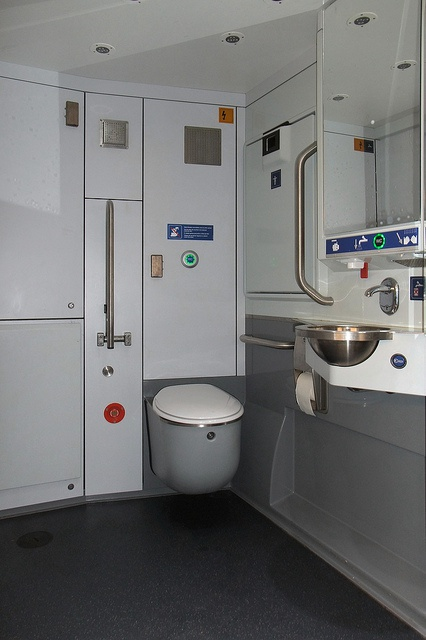Describe the objects in this image and their specific colors. I can see toilet in gray, darkgray, black, and lightgray tones and sink in gray and black tones in this image. 